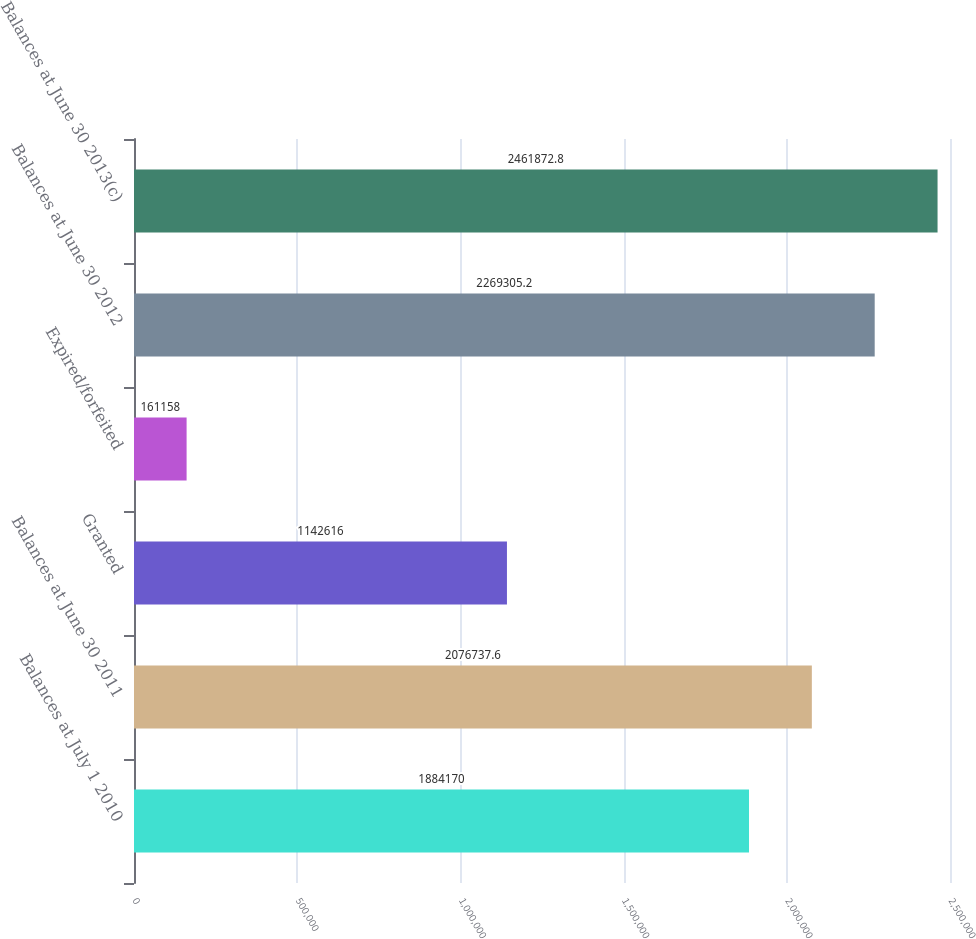Convert chart. <chart><loc_0><loc_0><loc_500><loc_500><bar_chart><fcel>Balances at July 1 2010<fcel>Balances at June 30 2011<fcel>Granted<fcel>Expired/forfeited<fcel>Balances at June 30 2012<fcel>Balances at June 30 2013(c)<nl><fcel>1.88417e+06<fcel>2.07674e+06<fcel>1.14262e+06<fcel>161158<fcel>2.26931e+06<fcel>2.46187e+06<nl></chart> 